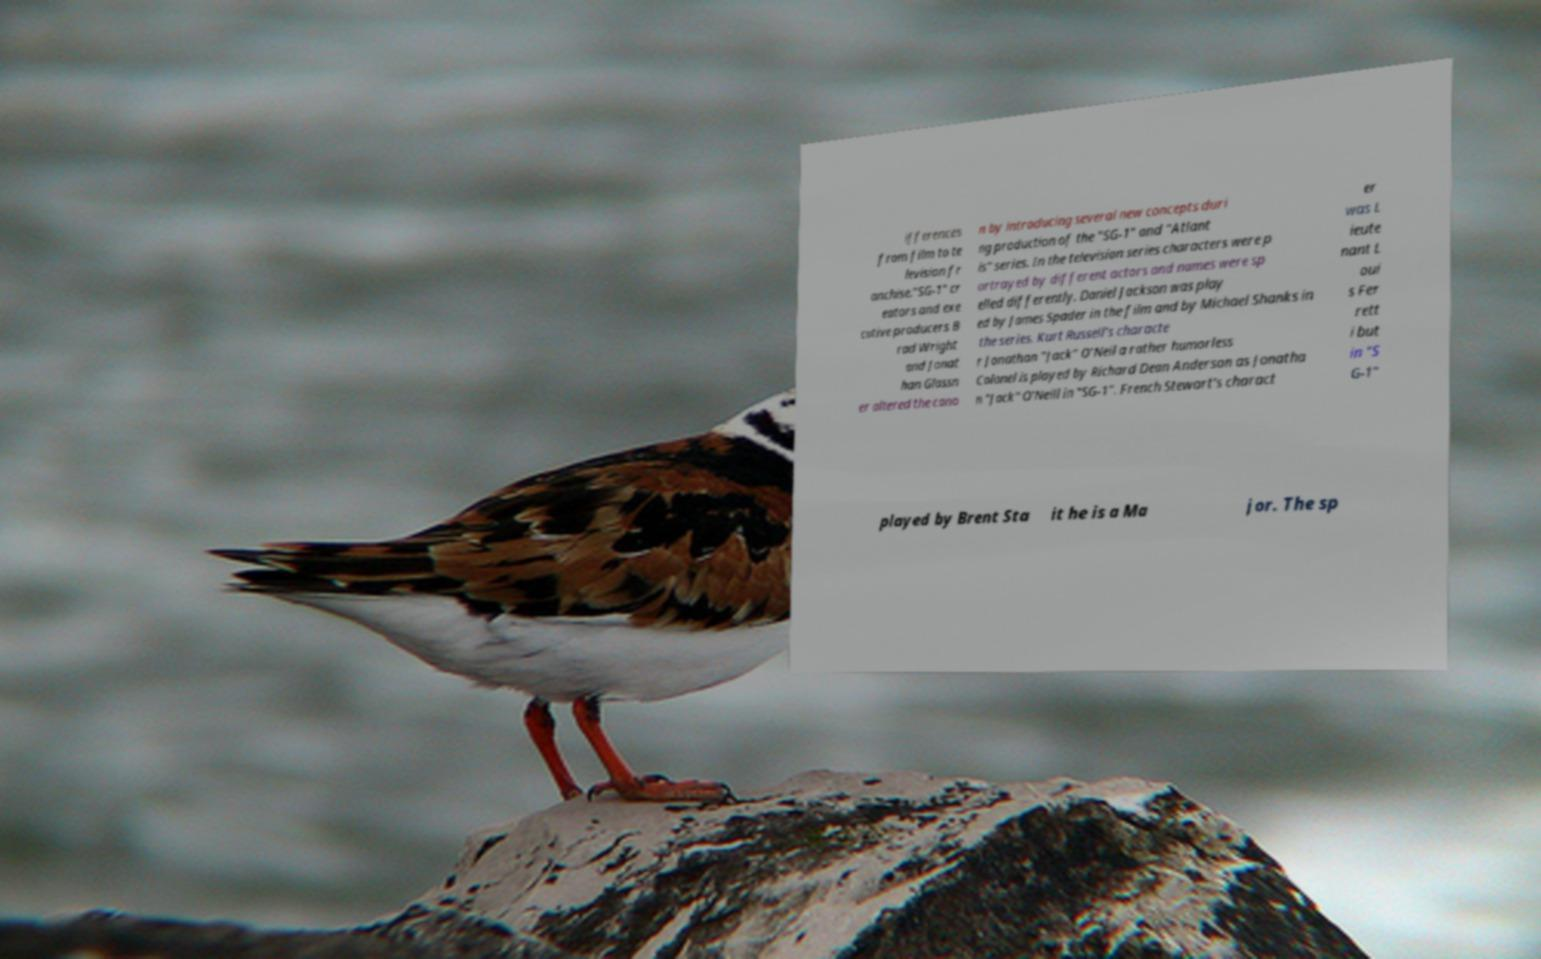Can you accurately transcribe the text from the provided image for me? ifferences from film to te levision fr anchise."SG-1" cr eators and exe cutive producers B rad Wright and Jonat han Glassn er altered the cano n by introducing several new concepts duri ng production of the "SG-1" and "Atlant is" series. In the television series characters were p ortrayed by different actors and names were sp elled differently. Daniel Jackson was play ed by James Spader in the film and by Michael Shanks in the series. Kurt Russell's characte r Jonathan "Jack" O'Neil a rather humorless Colonel is played by Richard Dean Anderson as Jonatha n "Jack" O'Neill in "SG-1". French Stewart's charact er was L ieute nant L oui s Fer rett i but in "S G-1" played by Brent Sta it he is a Ma jor. The sp 